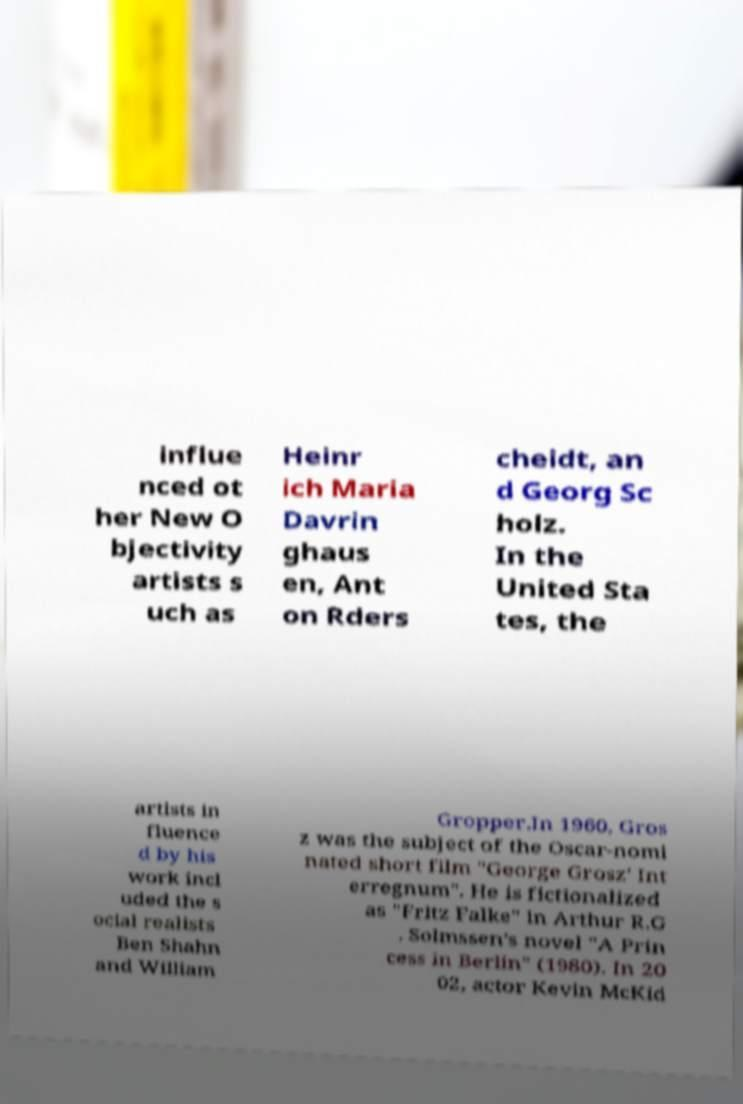For documentation purposes, I need the text within this image transcribed. Could you provide that? influe nced ot her New O bjectivity artists s uch as Heinr ich Maria Davrin ghaus en, Ant on Rders cheidt, an d Georg Sc holz. In the United Sta tes, the artists in fluence d by his work incl uded the s ocial realists Ben Shahn and William Gropper.In 1960, Gros z was the subject of the Oscar-nomi nated short film "George Grosz' Int erregnum". He is fictionalized as "Fritz Falke" in Arthur R.G . Solmssen's novel "A Prin cess in Berlin" (1980). In 20 02, actor Kevin McKid 